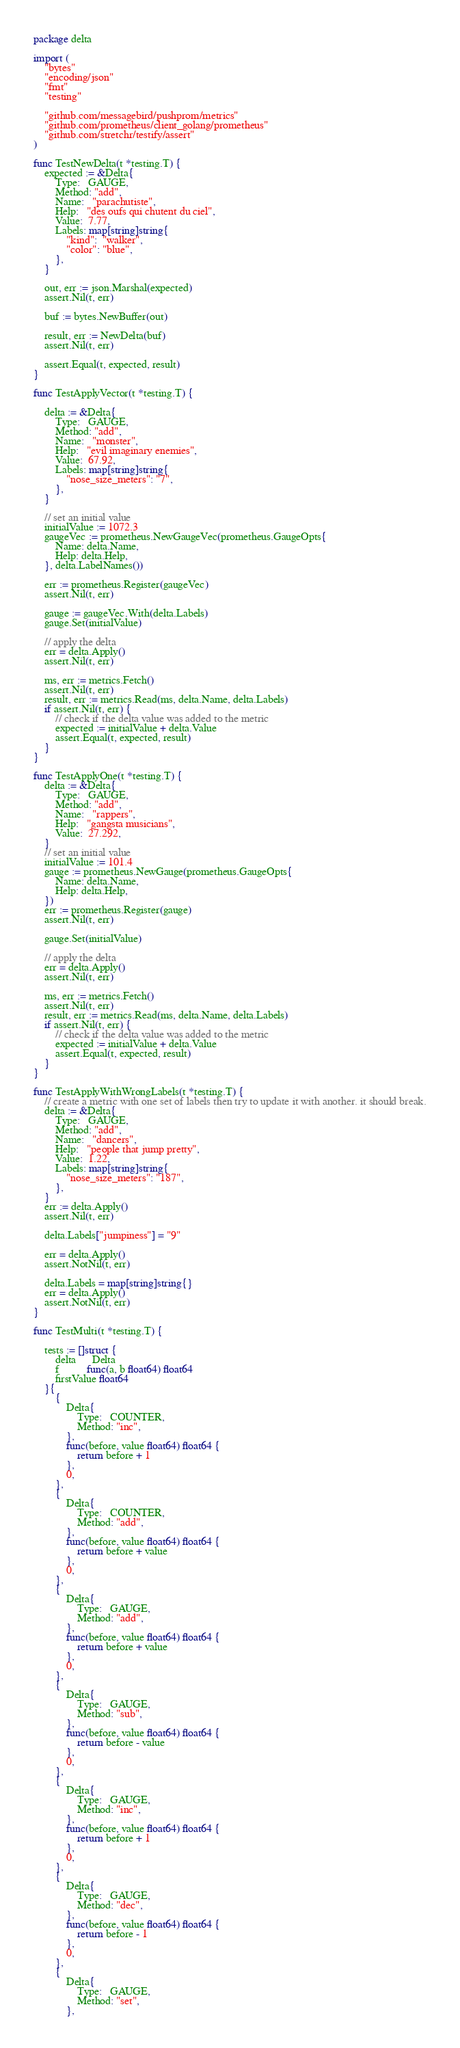<code> <loc_0><loc_0><loc_500><loc_500><_Go_>package delta

import (
	"bytes"
	"encoding/json"
	"fmt"
	"testing"

	"github.com/messagebird/pushprom/metrics"
	"github.com/prometheus/client_golang/prometheus"
	"github.com/stretchr/testify/assert"
)

func TestNewDelta(t *testing.T) {
	expected := &Delta{
		Type:   GAUGE,
		Method: "add",
		Name:   "parachutiste",
		Help:   "des oufs qui chutent du ciel",
		Value:  7.77,
		Labels: map[string]string{
			"kind":  "walker",
			"color": "blue",
		},
	}

	out, err := json.Marshal(expected)
	assert.Nil(t, err)

	buf := bytes.NewBuffer(out)

	result, err := NewDelta(buf)
	assert.Nil(t, err)

	assert.Equal(t, expected, result)
}

func TestApplyVector(t *testing.T) {

	delta := &Delta{
		Type:   GAUGE,
		Method: "add",
		Name:   "monster",
		Help:   "evil imaginary enemies",
		Value:  67.92,
		Labels: map[string]string{
			"nose_size_meters": "7",
		},
	}

	// set an initial value
	initialValue := 1072.3
	gaugeVec := prometheus.NewGaugeVec(prometheus.GaugeOpts{
		Name: delta.Name,
		Help: delta.Help,
	}, delta.LabelNames())

	err := prometheus.Register(gaugeVec)
	assert.Nil(t, err)

	gauge := gaugeVec.With(delta.Labels)
	gauge.Set(initialValue)

	// apply the delta
	err = delta.Apply()
	assert.Nil(t, err)

	ms, err := metrics.Fetch()
	assert.Nil(t, err)
	result, err := metrics.Read(ms, delta.Name, delta.Labels)
	if assert.Nil(t, err) {
		// check if the delta value was added to the metric
		expected := initialValue + delta.Value
		assert.Equal(t, expected, result)
	}
}

func TestApplyOne(t *testing.T) {
	delta := &Delta{
		Type:   GAUGE,
		Method: "add",
		Name:   "rappers",
		Help:   "gangsta musicians",
		Value:  27.292,
	}
	// set an initial value
	initialValue := 101.4
	gauge := prometheus.NewGauge(prometheus.GaugeOpts{
		Name: delta.Name,
		Help: delta.Help,
	})
	err := prometheus.Register(gauge)
	assert.Nil(t, err)

	gauge.Set(initialValue)

	// apply the delta
	err = delta.Apply()
	assert.Nil(t, err)

	ms, err := metrics.Fetch()
	assert.Nil(t, err)
	result, err := metrics.Read(ms, delta.Name, delta.Labels)
	if assert.Nil(t, err) {
		// check if the delta value was added to the metric
		expected := initialValue + delta.Value
		assert.Equal(t, expected, result)
	}
}

func TestApplyWithWrongLabels(t *testing.T) {
	// create a metric with one set of labels then try to update it with another. it should break.
	delta := &Delta{
		Type:   GAUGE,
		Method: "add",
		Name:   "dancers",
		Help:   "people that jump pretty",
		Value:  1.22,
		Labels: map[string]string{
			"nose_size_meters": "187",
		},
	}
	err := delta.Apply()
	assert.Nil(t, err)

	delta.Labels["jumpiness"] = "9"

	err = delta.Apply()
	assert.NotNil(t, err)

	delta.Labels = map[string]string{}
	err = delta.Apply()
	assert.NotNil(t, err)
}

func TestMulti(t *testing.T) {

	tests := []struct {
		delta      Delta
		f          func(a, b float64) float64
		firstValue float64
	}{
		{
			Delta{
				Type:   COUNTER,
				Method: "inc",
			},
			func(before, value float64) float64 {
				return before + 1
			},
			0,
		},
		{
			Delta{
				Type:   COUNTER,
				Method: "add",
			},
			func(before, value float64) float64 {
				return before + value
			},
			0,
		},
		{
			Delta{
				Type:   GAUGE,
				Method: "add",
			},
			func(before, value float64) float64 {
				return before + value
			},
			0,
		},
		{
			Delta{
				Type:   GAUGE,
				Method: "sub",
			},
			func(before, value float64) float64 {
				return before - value
			},
			0,
		},
		{
			Delta{
				Type:   GAUGE,
				Method: "inc",
			},
			func(before, value float64) float64 {
				return before + 1
			},
			0,
		},
		{
			Delta{
				Type:   GAUGE,
				Method: "dec",
			},
			func(before, value float64) float64 {
				return before - 1
			},
			0,
		},
		{
			Delta{
				Type:   GAUGE,
				Method: "set",
			},</code> 